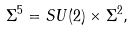Convert formula to latex. <formula><loc_0><loc_0><loc_500><loc_500>\Sigma ^ { 5 } = S U ( 2 ) \times \Sigma ^ { 2 } ,</formula> 